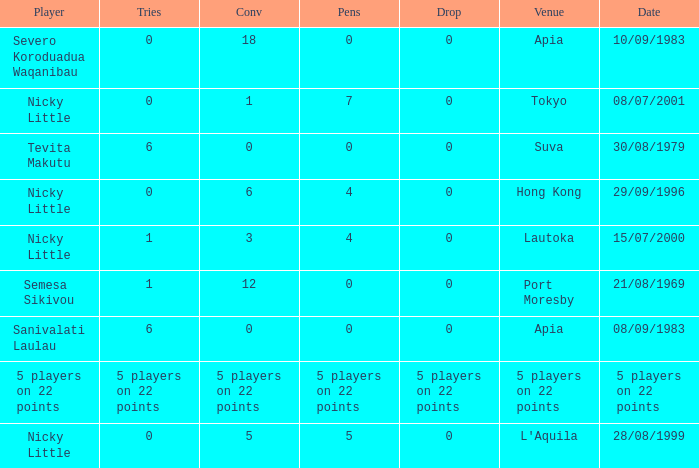Would you mind parsing the complete table? {'header': ['Player', 'Tries', 'Conv', 'Pens', 'Drop', 'Venue', 'Date'], 'rows': [['Severo Koroduadua Waqanibau', '0', '18', '0', '0', 'Apia', '10/09/1983'], ['Nicky Little', '0', '1', '7', '0', 'Tokyo', '08/07/2001'], ['Tevita Makutu', '6', '0', '0', '0', 'Suva', '30/08/1979'], ['Nicky Little', '0', '6', '4', '0', 'Hong Kong', '29/09/1996'], ['Nicky Little', '1', '3', '4', '0', 'Lautoka', '15/07/2000'], ['Semesa Sikivou', '1', '12', '0', '0', 'Port Moresby', '21/08/1969'], ['Sanivalati Laulau', '6', '0', '0', '0', 'Apia', '08/09/1983'], ['5 players on 22 points', '5 players on 22 points', '5 players on 22 points', '5 players on 22 points', '5 players on 22 points', '5 players on 22 points', '5 players on 22 points'], ['Nicky Little', '0', '5', '5', '0', "L'Aquila", '28/08/1999']]} How many conversions had 0 pens and 0 tries? 18.0. 